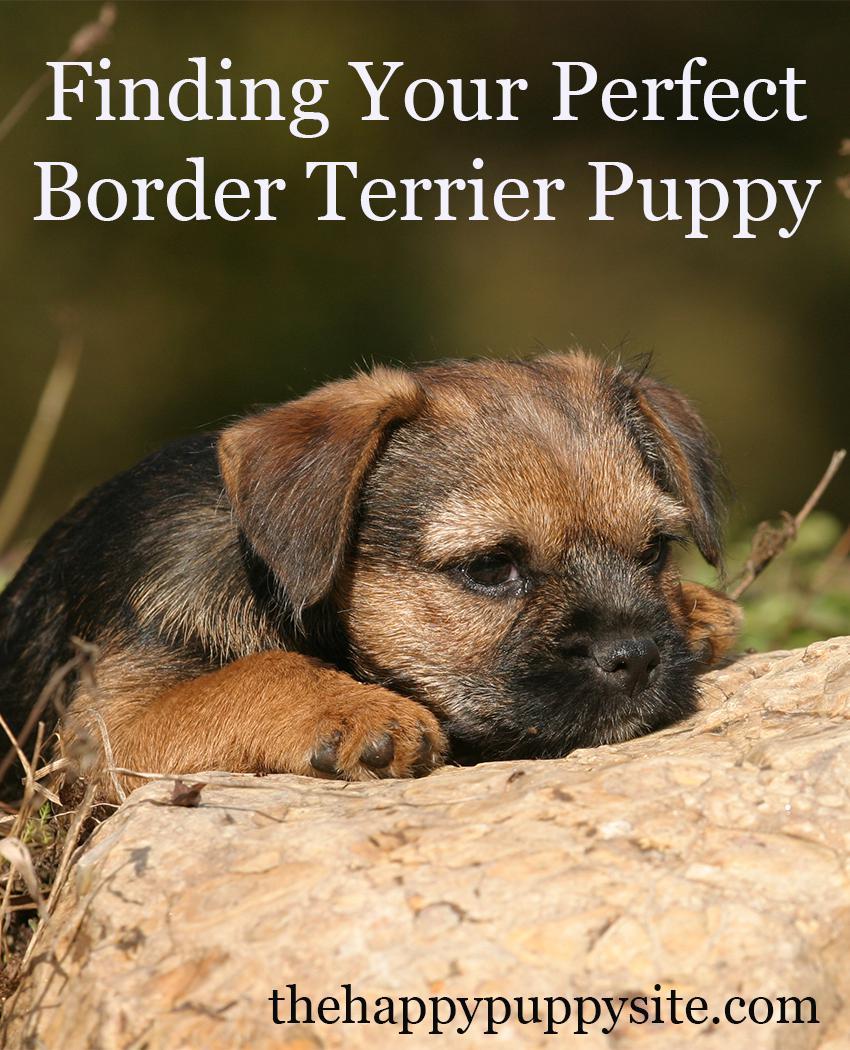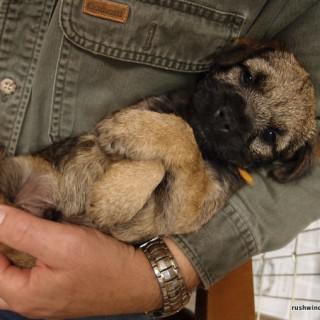The first image is the image on the left, the second image is the image on the right. Given the left and right images, does the statement "The puppy on the left is running, while the one on the right is not." hold true? Answer yes or no. No. 